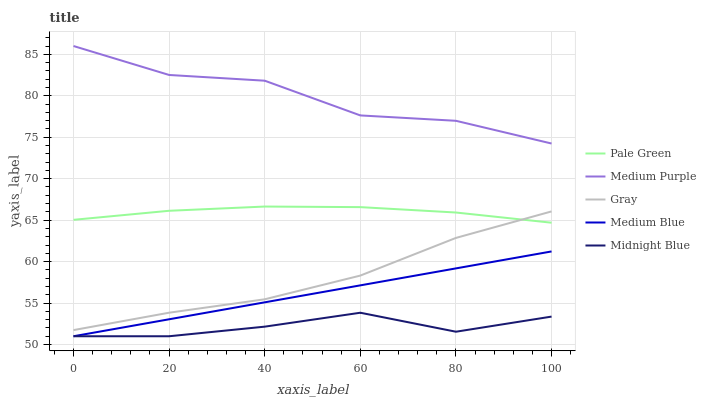Does Midnight Blue have the minimum area under the curve?
Answer yes or no. Yes. Does Medium Purple have the maximum area under the curve?
Answer yes or no. Yes. Does Gray have the minimum area under the curve?
Answer yes or no. No. Does Gray have the maximum area under the curve?
Answer yes or no. No. Is Medium Blue the smoothest?
Answer yes or no. Yes. Is Medium Purple the roughest?
Answer yes or no. Yes. Is Gray the smoothest?
Answer yes or no. No. Is Gray the roughest?
Answer yes or no. No. Does Gray have the lowest value?
Answer yes or no. No. Does Medium Purple have the highest value?
Answer yes or no. Yes. Does Gray have the highest value?
Answer yes or no. No. Is Midnight Blue less than Gray?
Answer yes or no. Yes. Is Gray greater than Medium Blue?
Answer yes or no. Yes. Does Midnight Blue intersect Medium Blue?
Answer yes or no. Yes. Is Midnight Blue less than Medium Blue?
Answer yes or no. No. Is Midnight Blue greater than Medium Blue?
Answer yes or no. No. Does Midnight Blue intersect Gray?
Answer yes or no. No. 